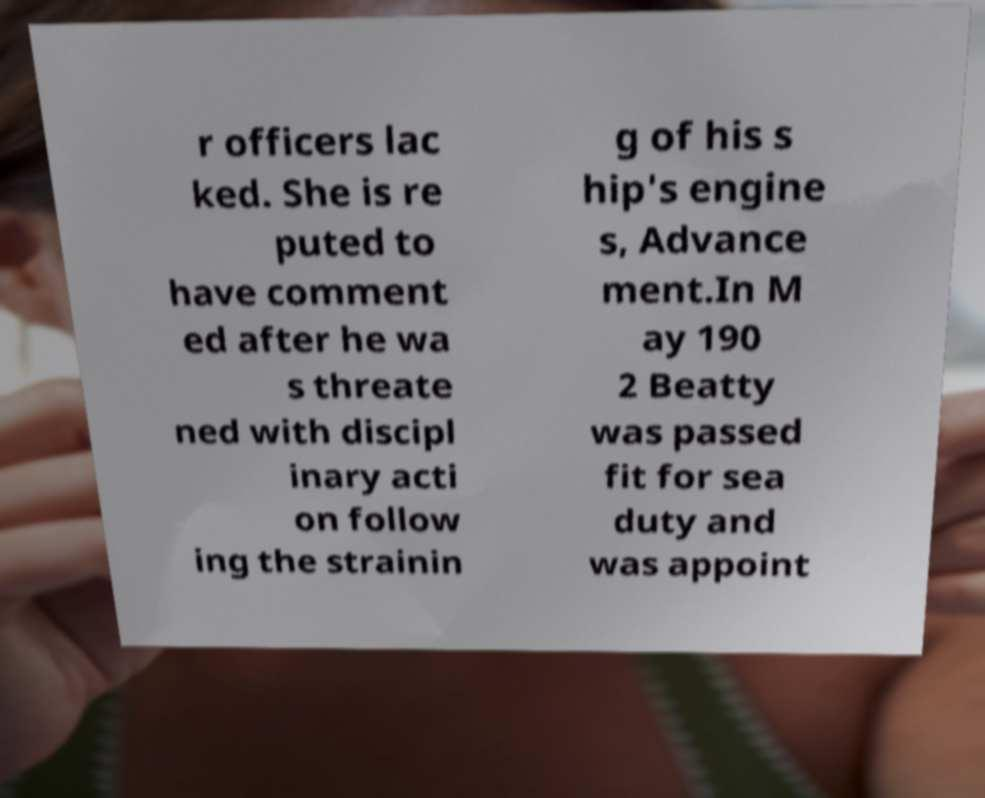Could you assist in decoding the text presented in this image and type it out clearly? r officers lac ked. She is re puted to have comment ed after he wa s threate ned with discipl inary acti on follow ing the strainin g of his s hip's engine s, Advance ment.In M ay 190 2 Beatty was passed fit for sea duty and was appoint 